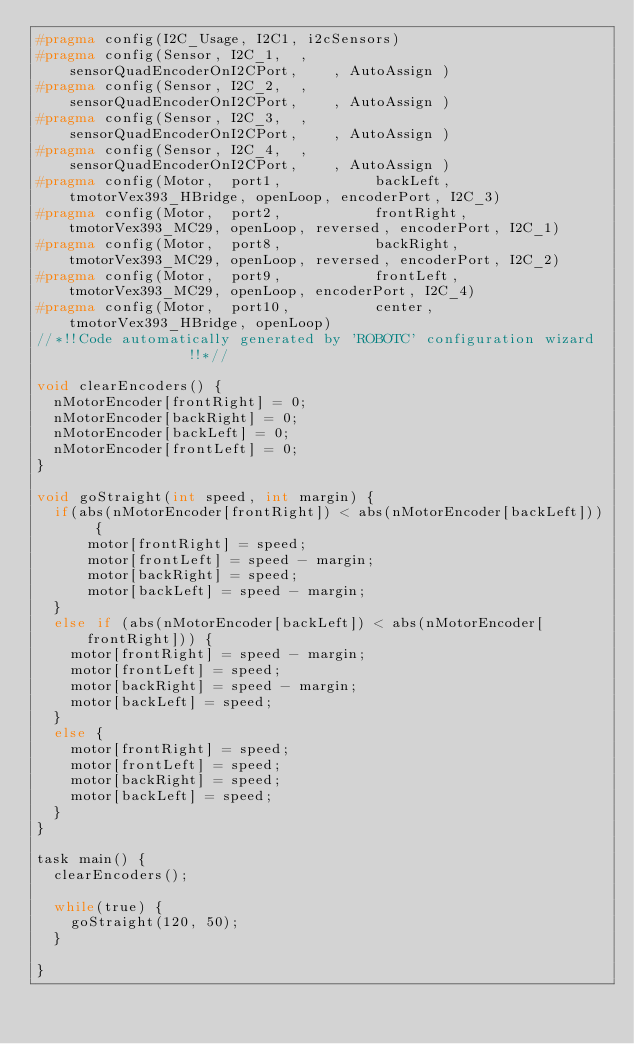<code> <loc_0><loc_0><loc_500><loc_500><_C_>#pragma config(I2C_Usage, I2C1, i2cSensors)
#pragma config(Sensor, I2C_1,  ,               sensorQuadEncoderOnI2CPort,    , AutoAssign )
#pragma config(Sensor, I2C_2,  ,               sensorQuadEncoderOnI2CPort,    , AutoAssign )
#pragma config(Sensor, I2C_3,  ,               sensorQuadEncoderOnI2CPort,    , AutoAssign )
#pragma config(Sensor, I2C_4,  ,               sensorQuadEncoderOnI2CPort,    , AutoAssign )
#pragma config(Motor,  port1,           backLeft,      tmotorVex393_HBridge, openLoop, encoderPort, I2C_3)
#pragma config(Motor,  port2,           frontRight,    tmotorVex393_MC29, openLoop, reversed, encoderPort, I2C_1)
#pragma config(Motor,  port8,           backRight,     tmotorVex393_MC29, openLoop, reversed, encoderPort, I2C_2)
#pragma config(Motor,  port9,           frontLeft,     tmotorVex393_MC29, openLoop, encoderPort, I2C_4)
#pragma config(Motor,  port10,          center,        tmotorVex393_HBridge, openLoop)
//*!!Code automatically generated by 'ROBOTC' configuration wizard               !!*//

void clearEncoders() {
	nMotorEncoder[frontRight] = 0;
	nMotorEncoder[backRight] = 0;
	nMotorEncoder[backLeft] = 0;
	nMotorEncoder[frontLeft] = 0;
}

void goStraight(int speed, int margin) {
	if(abs(nMotorEncoder[frontRight]) < abs(nMotorEncoder[backLeft])) {
			motor[frontRight] = speed;
			motor[frontLeft] = speed - margin;
			motor[backRight] = speed;
			motor[backLeft] = speed - margin;
	}
	else if (abs(nMotorEncoder[backLeft]) < abs(nMotorEncoder[frontRight])) {
		motor[frontRight] = speed - margin;
		motor[frontLeft] = speed;
		motor[backRight] = speed - margin;
		motor[backLeft] = speed;
	}
	else {
		motor[frontRight] = speed;
		motor[frontLeft] = speed;
		motor[backRight] = speed;
		motor[backLeft] = speed;
	}
}

task main() {
	clearEncoders();

	while(true) {
		goStraight(120, 50);
	}

}
</code> 